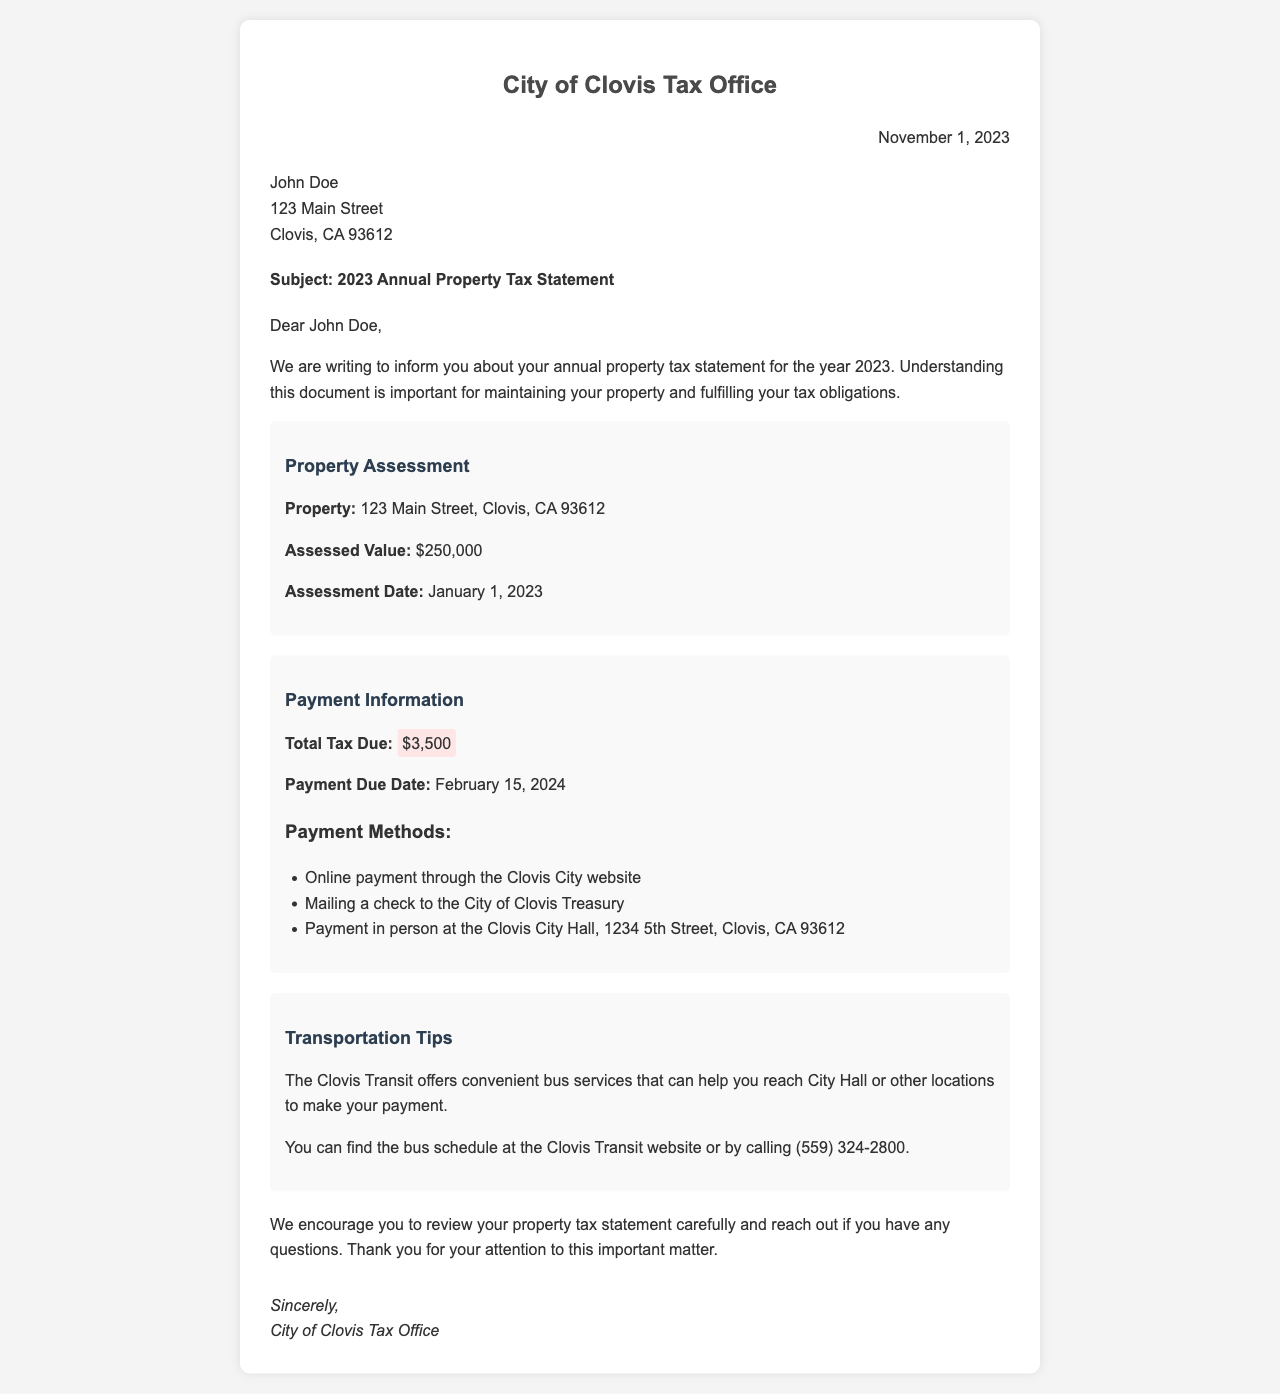What is the assessed value of the property? The assessed value is explicitly stated in the document under the Property Assessment section.
Answer: $250,000 When is the payment due? The document specifies the payment due date in the Payment Information section.
Answer: February 15, 2024 What is the total tax due? The total tax due is highlighted in the Payment Information section of the document.
Answer: $3,500 What is the assessment date? The assessment date is mentioned in the Property Assessment section.
Answer: January 1, 2023 What is one method of payment mentioned? The document lists several payment methods in the Payment Information section.
Answer: Online payment What address is associated with the property? The property address is provided in the Property Assessment section.
Answer: 123 Main Street, Clovis, CA 93612 Which office sent this letter? The sender's information is in the header of the document.
Answer: City of Clovis Tax Office How can I reach City Hall by bus? The document provides tips on using public transit to reach City Hall.
Answer: Clovis Transit offers convenient bus services What should I do if I have questions about my property tax statement? The conclusion of the document suggests an action for any inquiries.
Answer: Reach out if you have any questions 